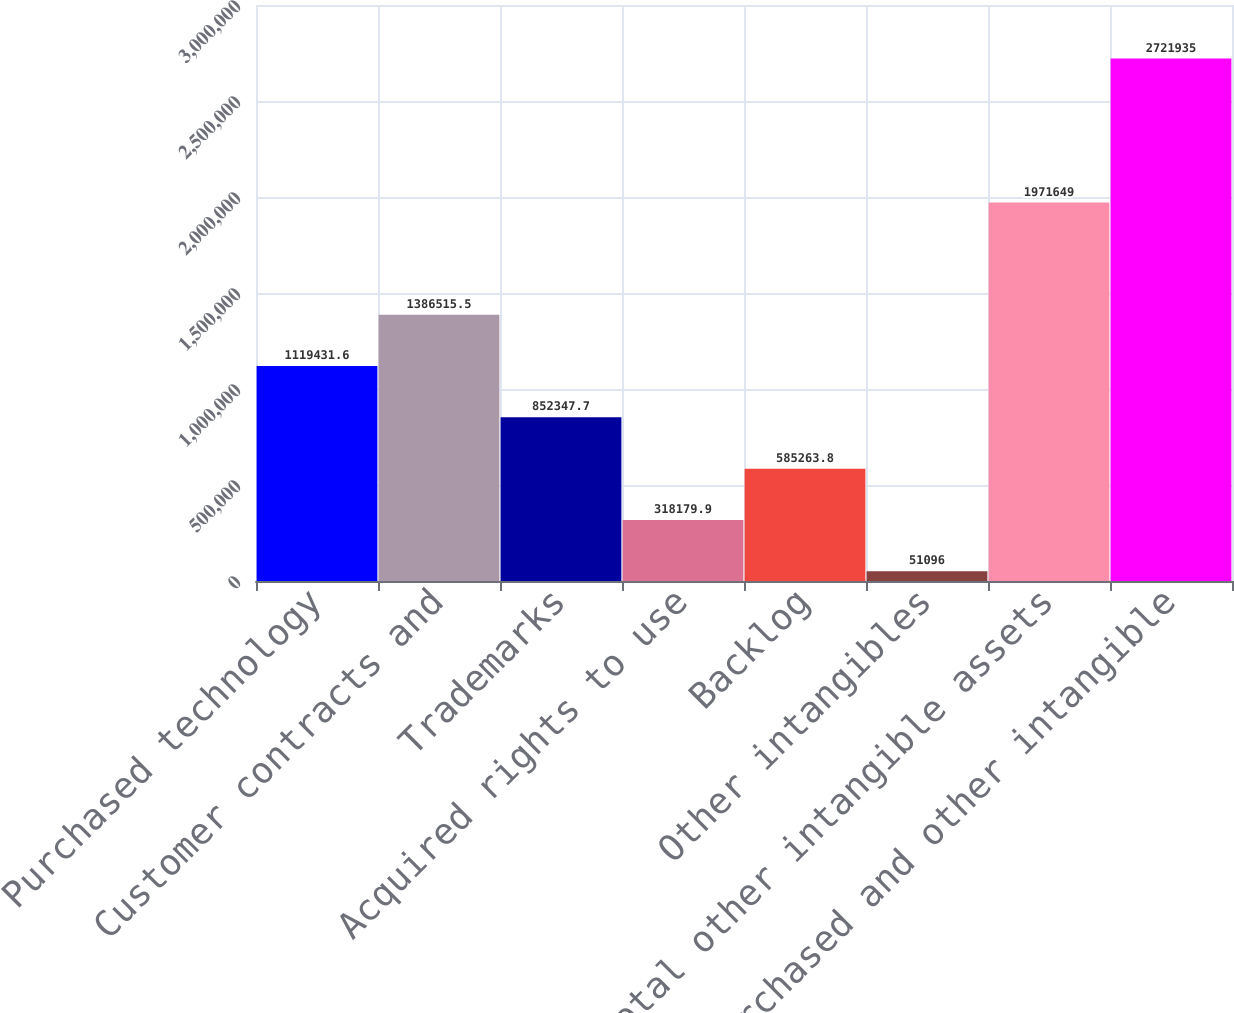Convert chart. <chart><loc_0><loc_0><loc_500><loc_500><bar_chart><fcel>Purchased technology<fcel>Customer contracts and<fcel>Trademarks<fcel>Acquired rights to use<fcel>Backlog<fcel>Other intangibles<fcel>Total other intangible assets<fcel>Purchased and other intangible<nl><fcel>1.11943e+06<fcel>1.38652e+06<fcel>852348<fcel>318180<fcel>585264<fcel>51096<fcel>1.97165e+06<fcel>2.72194e+06<nl></chart> 